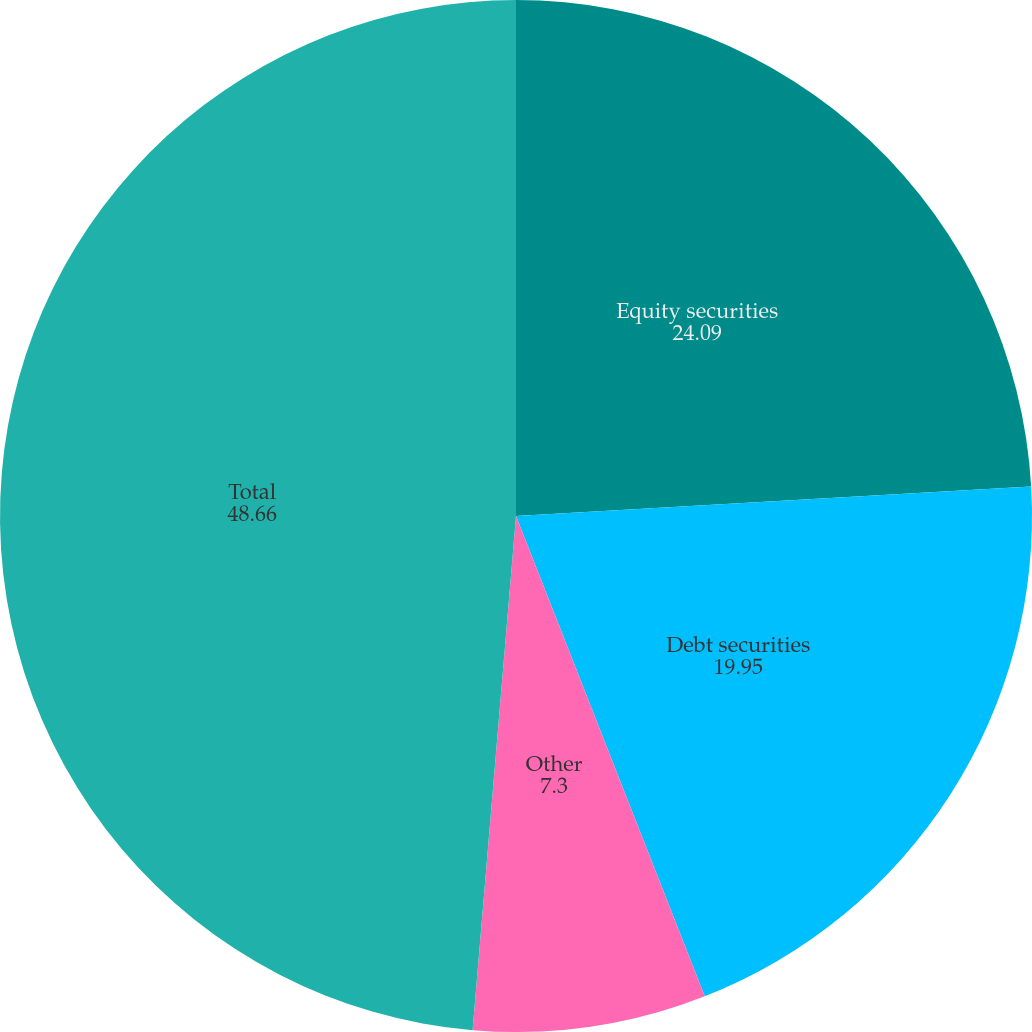Convert chart. <chart><loc_0><loc_0><loc_500><loc_500><pie_chart><fcel>Equity securities<fcel>Debt securities<fcel>Other<fcel>Total<nl><fcel>24.09%<fcel>19.95%<fcel>7.3%<fcel>48.66%<nl></chart> 